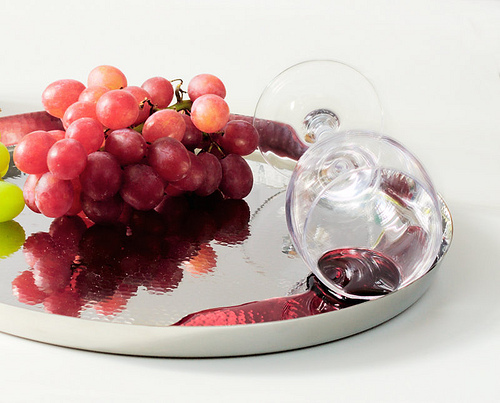<image>
Is the grape above the tray? No. The grape is not positioned above the tray. The vertical arrangement shows a different relationship. Is the fruit on the table? Yes. Looking at the image, I can see the fruit is positioned on top of the table, with the table providing support. 